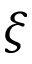<formula> <loc_0><loc_0><loc_500><loc_500>\xi</formula> 